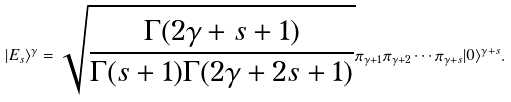Convert formula to latex. <formula><loc_0><loc_0><loc_500><loc_500>| E _ { s } \rangle ^ { \gamma } = \sqrt { \frac { \Gamma ( 2 \gamma + s + 1 ) } { \Gamma ( s + 1 ) \Gamma ( 2 \gamma + 2 s + 1 ) } } \pi _ { \gamma + 1 } \pi _ { \gamma + 2 } \cdots \pi _ { \gamma + s } | 0 \rangle ^ { \gamma + s } .</formula> 